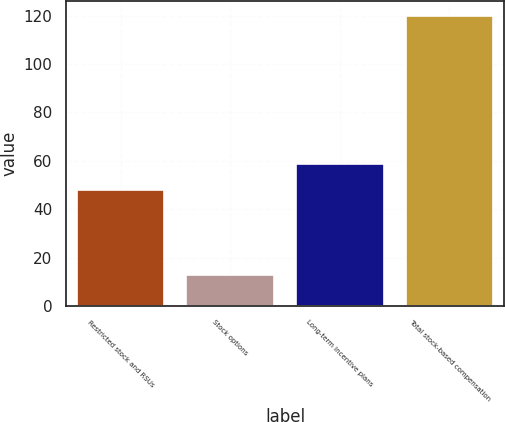Convert chart to OTSL. <chart><loc_0><loc_0><loc_500><loc_500><bar_chart><fcel>Restricted stock and RSUs<fcel>Stock options<fcel>Long-term incentive plans<fcel>Total stock-based compensation<nl><fcel>48<fcel>13<fcel>58.7<fcel>120<nl></chart> 